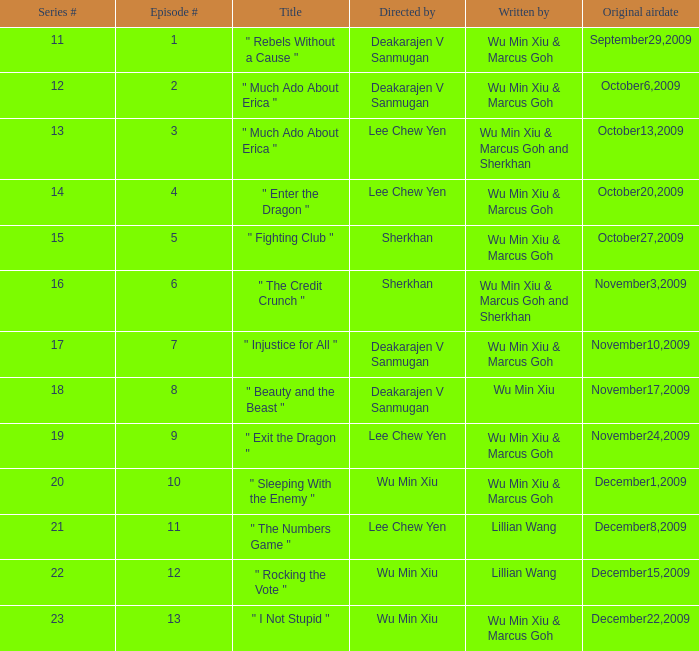What is the episode numeral for season 17? 7.0. 